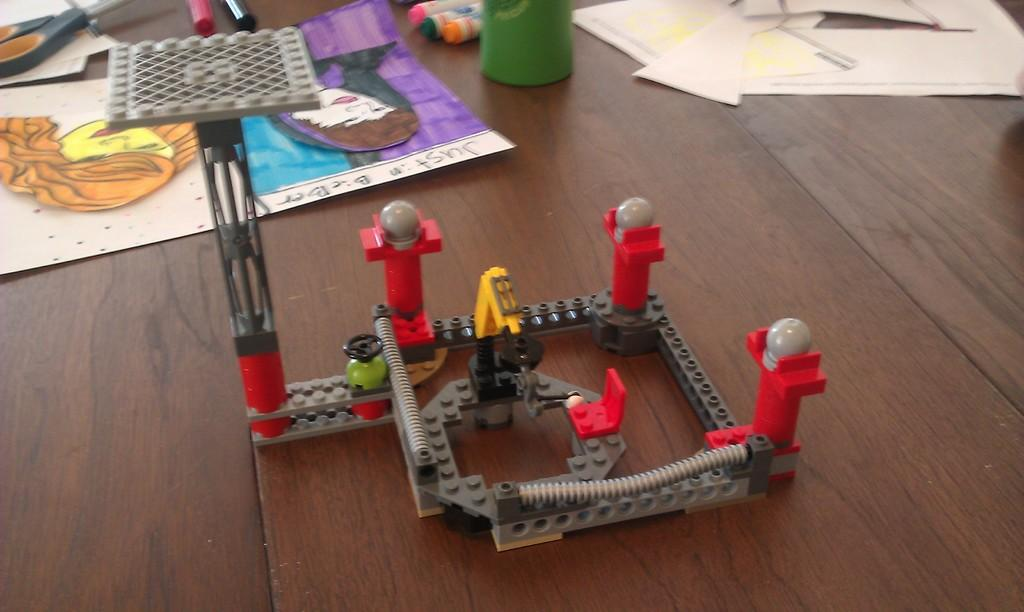What is the main piece of furniture in the image? There is a table in the image. What is placed on the table? There is a painting, a toy, papers, markers, and a scissor on the table. What type of art is visible on the table? There is a painting on the table. What stationery items are present on the table? There are markers and papers on the table. What type of jewel is hanging from the toy in the image? There is no jewel present in the image; the toy and other items are described in the provided facts. 